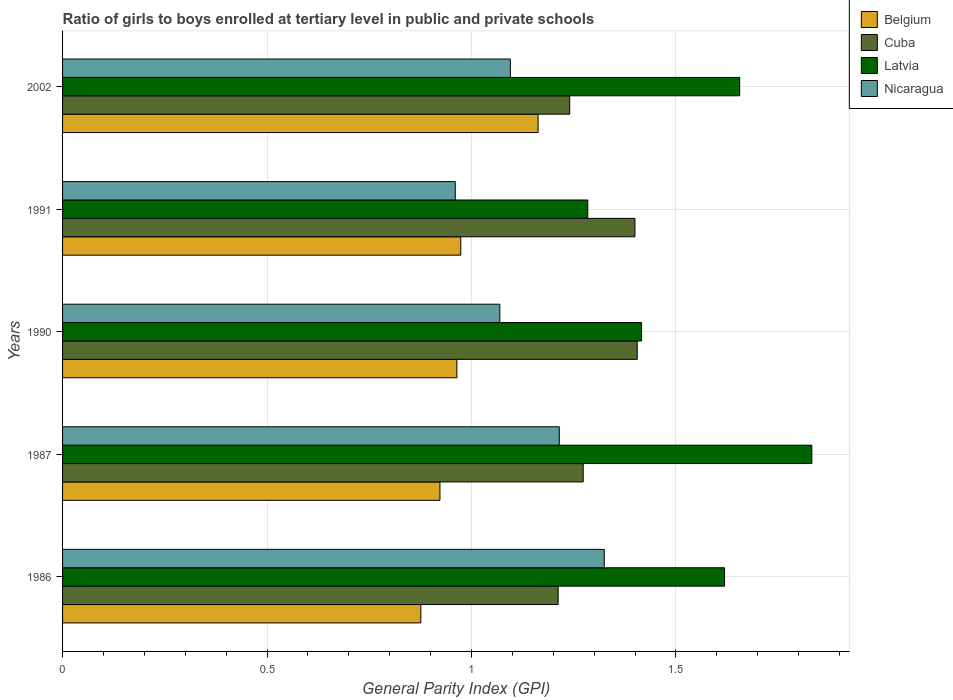Are the number of bars on each tick of the Y-axis equal?
Ensure brevity in your answer.  Yes. How many bars are there on the 1st tick from the top?
Provide a short and direct response. 4. What is the label of the 5th group of bars from the top?
Keep it short and to the point. 1986. In how many cases, is the number of bars for a given year not equal to the number of legend labels?
Your answer should be very brief. 0. What is the general parity index in Cuba in 2002?
Your response must be concise. 1.24. Across all years, what is the maximum general parity index in Cuba?
Give a very brief answer. 1.41. Across all years, what is the minimum general parity index in Cuba?
Provide a succinct answer. 1.21. What is the total general parity index in Belgium in the graph?
Your answer should be very brief. 4.9. What is the difference between the general parity index in Latvia in 1990 and that in 1991?
Your answer should be compact. 0.13. What is the difference between the general parity index in Nicaragua in 1991 and the general parity index in Cuba in 1986?
Make the answer very short. -0.25. What is the average general parity index in Nicaragua per year?
Offer a very short reply. 1.13. In the year 1987, what is the difference between the general parity index in Cuba and general parity index in Latvia?
Make the answer very short. -0.56. In how many years, is the general parity index in Latvia greater than 0.4 ?
Give a very brief answer. 5. What is the ratio of the general parity index in Latvia in 1991 to that in 2002?
Your answer should be compact. 0.78. Is the general parity index in Latvia in 1986 less than that in 2002?
Keep it short and to the point. Yes. Is the difference between the general parity index in Cuba in 1987 and 1991 greater than the difference between the general parity index in Latvia in 1987 and 1991?
Your response must be concise. No. What is the difference between the highest and the second highest general parity index in Latvia?
Give a very brief answer. 0.18. What is the difference between the highest and the lowest general parity index in Nicaragua?
Provide a succinct answer. 0.36. What does the 4th bar from the top in 2002 represents?
Your answer should be compact. Belgium. What does the 4th bar from the bottom in 1990 represents?
Your answer should be compact. Nicaragua. How many bars are there?
Your answer should be compact. 20. Are all the bars in the graph horizontal?
Your answer should be compact. Yes. Does the graph contain any zero values?
Your response must be concise. No. Does the graph contain grids?
Provide a short and direct response. Yes. How many legend labels are there?
Keep it short and to the point. 4. How are the legend labels stacked?
Provide a succinct answer. Vertical. What is the title of the graph?
Offer a very short reply. Ratio of girls to boys enrolled at tertiary level in public and private schools. What is the label or title of the X-axis?
Give a very brief answer. General Parity Index (GPI). What is the General Parity Index (GPI) in Belgium in 1986?
Keep it short and to the point. 0.88. What is the General Parity Index (GPI) in Cuba in 1986?
Keep it short and to the point. 1.21. What is the General Parity Index (GPI) in Latvia in 1986?
Provide a succinct answer. 1.62. What is the General Parity Index (GPI) in Nicaragua in 1986?
Keep it short and to the point. 1.32. What is the General Parity Index (GPI) of Belgium in 1987?
Make the answer very short. 0.92. What is the General Parity Index (GPI) in Cuba in 1987?
Give a very brief answer. 1.27. What is the General Parity Index (GPI) of Latvia in 1987?
Keep it short and to the point. 1.83. What is the General Parity Index (GPI) in Nicaragua in 1987?
Offer a very short reply. 1.21. What is the General Parity Index (GPI) in Belgium in 1990?
Provide a succinct answer. 0.96. What is the General Parity Index (GPI) of Cuba in 1990?
Your response must be concise. 1.41. What is the General Parity Index (GPI) of Latvia in 1990?
Your answer should be very brief. 1.42. What is the General Parity Index (GPI) in Nicaragua in 1990?
Provide a succinct answer. 1.07. What is the General Parity Index (GPI) in Belgium in 1991?
Your response must be concise. 0.97. What is the General Parity Index (GPI) in Cuba in 1991?
Give a very brief answer. 1.4. What is the General Parity Index (GPI) of Latvia in 1991?
Keep it short and to the point. 1.28. What is the General Parity Index (GPI) of Nicaragua in 1991?
Keep it short and to the point. 0.96. What is the General Parity Index (GPI) of Belgium in 2002?
Provide a succinct answer. 1.16. What is the General Parity Index (GPI) of Cuba in 2002?
Offer a very short reply. 1.24. What is the General Parity Index (GPI) of Latvia in 2002?
Provide a succinct answer. 1.66. What is the General Parity Index (GPI) in Nicaragua in 2002?
Provide a succinct answer. 1.1. Across all years, what is the maximum General Parity Index (GPI) in Belgium?
Your response must be concise. 1.16. Across all years, what is the maximum General Parity Index (GPI) of Cuba?
Keep it short and to the point. 1.41. Across all years, what is the maximum General Parity Index (GPI) of Latvia?
Ensure brevity in your answer.  1.83. Across all years, what is the maximum General Parity Index (GPI) of Nicaragua?
Ensure brevity in your answer.  1.32. Across all years, what is the minimum General Parity Index (GPI) in Belgium?
Provide a succinct answer. 0.88. Across all years, what is the minimum General Parity Index (GPI) in Cuba?
Keep it short and to the point. 1.21. Across all years, what is the minimum General Parity Index (GPI) in Latvia?
Ensure brevity in your answer.  1.28. Across all years, what is the minimum General Parity Index (GPI) of Nicaragua?
Provide a succinct answer. 0.96. What is the total General Parity Index (GPI) in Belgium in the graph?
Ensure brevity in your answer.  4.9. What is the total General Parity Index (GPI) in Cuba in the graph?
Provide a succinct answer. 6.53. What is the total General Parity Index (GPI) of Latvia in the graph?
Your answer should be very brief. 7.81. What is the total General Parity Index (GPI) in Nicaragua in the graph?
Make the answer very short. 5.66. What is the difference between the General Parity Index (GPI) of Belgium in 1986 and that in 1987?
Give a very brief answer. -0.05. What is the difference between the General Parity Index (GPI) of Cuba in 1986 and that in 1987?
Offer a very short reply. -0.06. What is the difference between the General Parity Index (GPI) in Latvia in 1986 and that in 1987?
Your answer should be very brief. -0.21. What is the difference between the General Parity Index (GPI) of Nicaragua in 1986 and that in 1987?
Provide a succinct answer. 0.11. What is the difference between the General Parity Index (GPI) of Belgium in 1986 and that in 1990?
Your answer should be compact. -0.09. What is the difference between the General Parity Index (GPI) in Cuba in 1986 and that in 1990?
Provide a short and direct response. -0.19. What is the difference between the General Parity Index (GPI) of Latvia in 1986 and that in 1990?
Keep it short and to the point. 0.2. What is the difference between the General Parity Index (GPI) of Nicaragua in 1986 and that in 1990?
Make the answer very short. 0.26. What is the difference between the General Parity Index (GPI) in Belgium in 1986 and that in 1991?
Ensure brevity in your answer.  -0.1. What is the difference between the General Parity Index (GPI) of Cuba in 1986 and that in 1991?
Your answer should be very brief. -0.19. What is the difference between the General Parity Index (GPI) in Latvia in 1986 and that in 1991?
Your answer should be very brief. 0.33. What is the difference between the General Parity Index (GPI) in Nicaragua in 1986 and that in 1991?
Make the answer very short. 0.36. What is the difference between the General Parity Index (GPI) of Belgium in 1986 and that in 2002?
Offer a very short reply. -0.29. What is the difference between the General Parity Index (GPI) in Cuba in 1986 and that in 2002?
Offer a terse response. -0.03. What is the difference between the General Parity Index (GPI) in Latvia in 1986 and that in 2002?
Ensure brevity in your answer.  -0.04. What is the difference between the General Parity Index (GPI) of Nicaragua in 1986 and that in 2002?
Provide a succinct answer. 0.23. What is the difference between the General Parity Index (GPI) of Belgium in 1987 and that in 1990?
Provide a succinct answer. -0.04. What is the difference between the General Parity Index (GPI) in Cuba in 1987 and that in 1990?
Make the answer very short. -0.13. What is the difference between the General Parity Index (GPI) of Latvia in 1987 and that in 1990?
Your answer should be compact. 0.42. What is the difference between the General Parity Index (GPI) of Nicaragua in 1987 and that in 1990?
Offer a very short reply. 0.15. What is the difference between the General Parity Index (GPI) of Belgium in 1987 and that in 1991?
Offer a terse response. -0.05. What is the difference between the General Parity Index (GPI) in Cuba in 1987 and that in 1991?
Make the answer very short. -0.13. What is the difference between the General Parity Index (GPI) of Latvia in 1987 and that in 1991?
Offer a terse response. 0.55. What is the difference between the General Parity Index (GPI) in Nicaragua in 1987 and that in 1991?
Provide a short and direct response. 0.25. What is the difference between the General Parity Index (GPI) of Belgium in 1987 and that in 2002?
Make the answer very short. -0.24. What is the difference between the General Parity Index (GPI) of Cuba in 1987 and that in 2002?
Your answer should be compact. 0.03. What is the difference between the General Parity Index (GPI) of Latvia in 1987 and that in 2002?
Your answer should be compact. 0.18. What is the difference between the General Parity Index (GPI) of Nicaragua in 1987 and that in 2002?
Provide a succinct answer. 0.12. What is the difference between the General Parity Index (GPI) in Belgium in 1990 and that in 1991?
Provide a short and direct response. -0.01. What is the difference between the General Parity Index (GPI) in Cuba in 1990 and that in 1991?
Your response must be concise. 0.01. What is the difference between the General Parity Index (GPI) of Latvia in 1990 and that in 1991?
Your answer should be very brief. 0.13. What is the difference between the General Parity Index (GPI) in Nicaragua in 1990 and that in 1991?
Keep it short and to the point. 0.11. What is the difference between the General Parity Index (GPI) in Belgium in 1990 and that in 2002?
Your answer should be very brief. -0.2. What is the difference between the General Parity Index (GPI) in Cuba in 1990 and that in 2002?
Your answer should be very brief. 0.17. What is the difference between the General Parity Index (GPI) in Latvia in 1990 and that in 2002?
Your response must be concise. -0.24. What is the difference between the General Parity Index (GPI) of Nicaragua in 1990 and that in 2002?
Your answer should be compact. -0.03. What is the difference between the General Parity Index (GPI) of Belgium in 1991 and that in 2002?
Ensure brevity in your answer.  -0.19. What is the difference between the General Parity Index (GPI) in Cuba in 1991 and that in 2002?
Ensure brevity in your answer.  0.16. What is the difference between the General Parity Index (GPI) of Latvia in 1991 and that in 2002?
Keep it short and to the point. -0.37. What is the difference between the General Parity Index (GPI) of Nicaragua in 1991 and that in 2002?
Your answer should be compact. -0.13. What is the difference between the General Parity Index (GPI) of Belgium in 1986 and the General Parity Index (GPI) of Cuba in 1987?
Your answer should be very brief. -0.4. What is the difference between the General Parity Index (GPI) in Belgium in 1986 and the General Parity Index (GPI) in Latvia in 1987?
Provide a short and direct response. -0.96. What is the difference between the General Parity Index (GPI) of Belgium in 1986 and the General Parity Index (GPI) of Nicaragua in 1987?
Offer a very short reply. -0.34. What is the difference between the General Parity Index (GPI) of Cuba in 1986 and the General Parity Index (GPI) of Latvia in 1987?
Ensure brevity in your answer.  -0.62. What is the difference between the General Parity Index (GPI) in Cuba in 1986 and the General Parity Index (GPI) in Nicaragua in 1987?
Your answer should be compact. -0. What is the difference between the General Parity Index (GPI) in Latvia in 1986 and the General Parity Index (GPI) in Nicaragua in 1987?
Give a very brief answer. 0.4. What is the difference between the General Parity Index (GPI) in Belgium in 1986 and the General Parity Index (GPI) in Cuba in 1990?
Your answer should be compact. -0.53. What is the difference between the General Parity Index (GPI) in Belgium in 1986 and the General Parity Index (GPI) in Latvia in 1990?
Your response must be concise. -0.54. What is the difference between the General Parity Index (GPI) in Belgium in 1986 and the General Parity Index (GPI) in Nicaragua in 1990?
Offer a very short reply. -0.19. What is the difference between the General Parity Index (GPI) in Cuba in 1986 and the General Parity Index (GPI) in Latvia in 1990?
Give a very brief answer. -0.2. What is the difference between the General Parity Index (GPI) in Cuba in 1986 and the General Parity Index (GPI) in Nicaragua in 1990?
Give a very brief answer. 0.14. What is the difference between the General Parity Index (GPI) in Latvia in 1986 and the General Parity Index (GPI) in Nicaragua in 1990?
Provide a short and direct response. 0.55. What is the difference between the General Parity Index (GPI) in Belgium in 1986 and the General Parity Index (GPI) in Cuba in 1991?
Provide a short and direct response. -0.52. What is the difference between the General Parity Index (GPI) of Belgium in 1986 and the General Parity Index (GPI) of Latvia in 1991?
Provide a succinct answer. -0.41. What is the difference between the General Parity Index (GPI) in Belgium in 1986 and the General Parity Index (GPI) in Nicaragua in 1991?
Your answer should be very brief. -0.08. What is the difference between the General Parity Index (GPI) of Cuba in 1986 and the General Parity Index (GPI) of Latvia in 1991?
Keep it short and to the point. -0.07. What is the difference between the General Parity Index (GPI) in Cuba in 1986 and the General Parity Index (GPI) in Nicaragua in 1991?
Make the answer very short. 0.25. What is the difference between the General Parity Index (GPI) of Latvia in 1986 and the General Parity Index (GPI) of Nicaragua in 1991?
Your response must be concise. 0.66. What is the difference between the General Parity Index (GPI) of Belgium in 1986 and the General Parity Index (GPI) of Cuba in 2002?
Your response must be concise. -0.36. What is the difference between the General Parity Index (GPI) in Belgium in 1986 and the General Parity Index (GPI) in Latvia in 2002?
Your answer should be very brief. -0.78. What is the difference between the General Parity Index (GPI) in Belgium in 1986 and the General Parity Index (GPI) in Nicaragua in 2002?
Give a very brief answer. -0.22. What is the difference between the General Parity Index (GPI) of Cuba in 1986 and the General Parity Index (GPI) of Latvia in 2002?
Offer a terse response. -0.44. What is the difference between the General Parity Index (GPI) of Cuba in 1986 and the General Parity Index (GPI) of Nicaragua in 2002?
Offer a terse response. 0.12. What is the difference between the General Parity Index (GPI) in Latvia in 1986 and the General Parity Index (GPI) in Nicaragua in 2002?
Ensure brevity in your answer.  0.52. What is the difference between the General Parity Index (GPI) in Belgium in 1987 and the General Parity Index (GPI) in Cuba in 1990?
Provide a succinct answer. -0.48. What is the difference between the General Parity Index (GPI) of Belgium in 1987 and the General Parity Index (GPI) of Latvia in 1990?
Your answer should be very brief. -0.49. What is the difference between the General Parity Index (GPI) of Belgium in 1987 and the General Parity Index (GPI) of Nicaragua in 1990?
Offer a terse response. -0.15. What is the difference between the General Parity Index (GPI) in Cuba in 1987 and the General Parity Index (GPI) in Latvia in 1990?
Ensure brevity in your answer.  -0.14. What is the difference between the General Parity Index (GPI) of Cuba in 1987 and the General Parity Index (GPI) of Nicaragua in 1990?
Give a very brief answer. 0.2. What is the difference between the General Parity Index (GPI) in Latvia in 1987 and the General Parity Index (GPI) in Nicaragua in 1990?
Provide a short and direct response. 0.76. What is the difference between the General Parity Index (GPI) of Belgium in 1987 and the General Parity Index (GPI) of Cuba in 1991?
Offer a terse response. -0.48. What is the difference between the General Parity Index (GPI) in Belgium in 1987 and the General Parity Index (GPI) in Latvia in 1991?
Offer a terse response. -0.36. What is the difference between the General Parity Index (GPI) in Belgium in 1987 and the General Parity Index (GPI) in Nicaragua in 1991?
Your response must be concise. -0.04. What is the difference between the General Parity Index (GPI) in Cuba in 1987 and the General Parity Index (GPI) in Latvia in 1991?
Your answer should be compact. -0.01. What is the difference between the General Parity Index (GPI) of Cuba in 1987 and the General Parity Index (GPI) of Nicaragua in 1991?
Ensure brevity in your answer.  0.31. What is the difference between the General Parity Index (GPI) in Latvia in 1987 and the General Parity Index (GPI) in Nicaragua in 1991?
Offer a very short reply. 0.87. What is the difference between the General Parity Index (GPI) in Belgium in 1987 and the General Parity Index (GPI) in Cuba in 2002?
Offer a terse response. -0.32. What is the difference between the General Parity Index (GPI) of Belgium in 1987 and the General Parity Index (GPI) of Latvia in 2002?
Ensure brevity in your answer.  -0.73. What is the difference between the General Parity Index (GPI) of Belgium in 1987 and the General Parity Index (GPI) of Nicaragua in 2002?
Keep it short and to the point. -0.17. What is the difference between the General Parity Index (GPI) of Cuba in 1987 and the General Parity Index (GPI) of Latvia in 2002?
Ensure brevity in your answer.  -0.38. What is the difference between the General Parity Index (GPI) in Cuba in 1987 and the General Parity Index (GPI) in Nicaragua in 2002?
Provide a short and direct response. 0.18. What is the difference between the General Parity Index (GPI) of Latvia in 1987 and the General Parity Index (GPI) of Nicaragua in 2002?
Make the answer very short. 0.74. What is the difference between the General Parity Index (GPI) of Belgium in 1990 and the General Parity Index (GPI) of Cuba in 1991?
Offer a terse response. -0.44. What is the difference between the General Parity Index (GPI) of Belgium in 1990 and the General Parity Index (GPI) of Latvia in 1991?
Your answer should be compact. -0.32. What is the difference between the General Parity Index (GPI) in Belgium in 1990 and the General Parity Index (GPI) in Nicaragua in 1991?
Make the answer very short. 0. What is the difference between the General Parity Index (GPI) in Cuba in 1990 and the General Parity Index (GPI) in Latvia in 1991?
Provide a short and direct response. 0.12. What is the difference between the General Parity Index (GPI) of Cuba in 1990 and the General Parity Index (GPI) of Nicaragua in 1991?
Make the answer very short. 0.45. What is the difference between the General Parity Index (GPI) of Latvia in 1990 and the General Parity Index (GPI) of Nicaragua in 1991?
Make the answer very short. 0.46. What is the difference between the General Parity Index (GPI) in Belgium in 1990 and the General Parity Index (GPI) in Cuba in 2002?
Keep it short and to the point. -0.28. What is the difference between the General Parity Index (GPI) in Belgium in 1990 and the General Parity Index (GPI) in Latvia in 2002?
Your response must be concise. -0.69. What is the difference between the General Parity Index (GPI) of Belgium in 1990 and the General Parity Index (GPI) of Nicaragua in 2002?
Your response must be concise. -0.13. What is the difference between the General Parity Index (GPI) in Cuba in 1990 and the General Parity Index (GPI) in Latvia in 2002?
Offer a terse response. -0.25. What is the difference between the General Parity Index (GPI) in Cuba in 1990 and the General Parity Index (GPI) in Nicaragua in 2002?
Your answer should be compact. 0.31. What is the difference between the General Parity Index (GPI) in Latvia in 1990 and the General Parity Index (GPI) in Nicaragua in 2002?
Offer a terse response. 0.32. What is the difference between the General Parity Index (GPI) in Belgium in 1991 and the General Parity Index (GPI) in Cuba in 2002?
Make the answer very short. -0.27. What is the difference between the General Parity Index (GPI) in Belgium in 1991 and the General Parity Index (GPI) in Latvia in 2002?
Ensure brevity in your answer.  -0.68. What is the difference between the General Parity Index (GPI) of Belgium in 1991 and the General Parity Index (GPI) of Nicaragua in 2002?
Offer a very short reply. -0.12. What is the difference between the General Parity Index (GPI) in Cuba in 1991 and the General Parity Index (GPI) in Latvia in 2002?
Your answer should be compact. -0.26. What is the difference between the General Parity Index (GPI) in Cuba in 1991 and the General Parity Index (GPI) in Nicaragua in 2002?
Provide a succinct answer. 0.3. What is the difference between the General Parity Index (GPI) of Latvia in 1991 and the General Parity Index (GPI) of Nicaragua in 2002?
Provide a succinct answer. 0.19. What is the average General Parity Index (GPI) in Belgium per year?
Your response must be concise. 0.98. What is the average General Parity Index (GPI) in Cuba per year?
Your answer should be very brief. 1.31. What is the average General Parity Index (GPI) of Latvia per year?
Offer a very short reply. 1.56. What is the average General Parity Index (GPI) in Nicaragua per year?
Ensure brevity in your answer.  1.13. In the year 1986, what is the difference between the General Parity Index (GPI) of Belgium and General Parity Index (GPI) of Cuba?
Your answer should be compact. -0.34. In the year 1986, what is the difference between the General Parity Index (GPI) of Belgium and General Parity Index (GPI) of Latvia?
Provide a short and direct response. -0.74. In the year 1986, what is the difference between the General Parity Index (GPI) of Belgium and General Parity Index (GPI) of Nicaragua?
Make the answer very short. -0.45. In the year 1986, what is the difference between the General Parity Index (GPI) of Cuba and General Parity Index (GPI) of Latvia?
Offer a terse response. -0.41. In the year 1986, what is the difference between the General Parity Index (GPI) of Cuba and General Parity Index (GPI) of Nicaragua?
Offer a very short reply. -0.11. In the year 1986, what is the difference between the General Parity Index (GPI) of Latvia and General Parity Index (GPI) of Nicaragua?
Make the answer very short. 0.29. In the year 1987, what is the difference between the General Parity Index (GPI) in Belgium and General Parity Index (GPI) in Cuba?
Your answer should be very brief. -0.35. In the year 1987, what is the difference between the General Parity Index (GPI) in Belgium and General Parity Index (GPI) in Latvia?
Give a very brief answer. -0.91. In the year 1987, what is the difference between the General Parity Index (GPI) in Belgium and General Parity Index (GPI) in Nicaragua?
Provide a succinct answer. -0.29. In the year 1987, what is the difference between the General Parity Index (GPI) in Cuba and General Parity Index (GPI) in Latvia?
Ensure brevity in your answer.  -0.56. In the year 1987, what is the difference between the General Parity Index (GPI) in Cuba and General Parity Index (GPI) in Nicaragua?
Provide a succinct answer. 0.06. In the year 1987, what is the difference between the General Parity Index (GPI) of Latvia and General Parity Index (GPI) of Nicaragua?
Your response must be concise. 0.62. In the year 1990, what is the difference between the General Parity Index (GPI) in Belgium and General Parity Index (GPI) in Cuba?
Offer a very short reply. -0.44. In the year 1990, what is the difference between the General Parity Index (GPI) in Belgium and General Parity Index (GPI) in Latvia?
Keep it short and to the point. -0.45. In the year 1990, what is the difference between the General Parity Index (GPI) in Belgium and General Parity Index (GPI) in Nicaragua?
Make the answer very short. -0.1. In the year 1990, what is the difference between the General Parity Index (GPI) of Cuba and General Parity Index (GPI) of Latvia?
Keep it short and to the point. -0.01. In the year 1990, what is the difference between the General Parity Index (GPI) of Cuba and General Parity Index (GPI) of Nicaragua?
Keep it short and to the point. 0.34. In the year 1990, what is the difference between the General Parity Index (GPI) of Latvia and General Parity Index (GPI) of Nicaragua?
Keep it short and to the point. 0.35. In the year 1991, what is the difference between the General Parity Index (GPI) in Belgium and General Parity Index (GPI) in Cuba?
Offer a very short reply. -0.43. In the year 1991, what is the difference between the General Parity Index (GPI) in Belgium and General Parity Index (GPI) in Latvia?
Your answer should be very brief. -0.31. In the year 1991, what is the difference between the General Parity Index (GPI) in Belgium and General Parity Index (GPI) in Nicaragua?
Your answer should be very brief. 0.01. In the year 1991, what is the difference between the General Parity Index (GPI) of Cuba and General Parity Index (GPI) of Latvia?
Your answer should be compact. 0.12. In the year 1991, what is the difference between the General Parity Index (GPI) in Cuba and General Parity Index (GPI) in Nicaragua?
Offer a very short reply. 0.44. In the year 1991, what is the difference between the General Parity Index (GPI) of Latvia and General Parity Index (GPI) of Nicaragua?
Keep it short and to the point. 0.32. In the year 2002, what is the difference between the General Parity Index (GPI) of Belgium and General Parity Index (GPI) of Cuba?
Your answer should be very brief. -0.08. In the year 2002, what is the difference between the General Parity Index (GPI) in Belgium and General Parity Index (GPI) in Latvia?
Offer a terse response. -0.49. In the year 2002, what is the difference between the General Parity Index (GPI) of Belgium and General Parity Index (GPI) of Nicaragua?
Make the answer very short. 0.07. In the year 2002, what is the difference between the General Parity Index (GPI) of Cuba and General Parity Index (GPI) of Latvia?
Make the answer very short. -0.42. In the year 2002, what is the difference between the General Parity Index (GPI) of Cuba and General Parity Index (GPI) of Nicaragua?
Provide a short and direct response. 0.14. In the year 2002, what is the difference between the General Parity Index (GPI) in Latvia and General Parity Index (GPI) in Nicaragua?
Provide a short and direct response. 0.56. What is the ratio of the General Parity Index (GPI) of Belgium in 1986 to that in 1987?
Provide a short and direct response. 0.95. What is the ratio of the General Parity Index (GPI) in Cuba in 1986 to that in 1987?
Give a very brief answer. 0.95. What is the ratio of the General Parity Index (GPI) in Latvia in 1986 to that in 1987?
Offer a very short reply. 0.88. What is the ratio of the General Parity Index (GPI) in Nicaragua in 1986 to that in 1987?
Offer a terse response. 1.09. What is the ratio of the General Parity Index (GPI) in Belgium in 1986 to that in 1990?
Your answer should be very brief. 0.91. What is the ratio of the General Parity Index (GPI) in Cuba in 1986 to that in 1990?
Offer a terse response. 0.86. What is the ratio of the General Parity Index (GPI) in Latvia in 1986 to that in 1990?
Give a very brief answer. 1.14. What is the ratio of the General Parity Index (GPI) in Nicaragua in 1986 to that in 1990?
Give a very brief answer. 1.24. What is the ratio of the General Parity Index (GPI) in Belgium in 1986 to that in 1991?
Keep it short and to the point. 0.9. What is the ratio of the General Parity Index (GPI) of Cuba in 1986 to that in 1991?
Ensure brevity in your answer.  0.87. What is the ratio of the General Parity Index (GPI) in Latvia in 1986 to that in 1991?
Offer a terse response. 1.26. What is the ratio of the General Parity Index (GPI) in Nicaragua in 1986 to that in 1991?
Provide a short and direct response. 1.38. What is the ratio of the General Parity Index (GPI) in Belgium in 1986 to that in 2002?
Provide a succinct answer. 0.75. What is the ratio of the General Parity Index (GPI) in Cuba in 1986 to that in 2002?
Your answer should be compact. 0.98. What is the ratio of the General Parity Index (GPI) in Latvia in 1986 to that in 2002?
Your answer should be compact. 0.98. What is the ratio of the General Parity Index (GPI) in Nicaragua in 1986 to that in 2002?
Provide a short and direct response. 1.21. What is the ratio of the General Parity Index (GPI) in Cuba in 1987 to that in 1990?
Ensure brevity in your answer.  0.91. What is the ratio of the General Parity Index (GPI) in Latvia in 1987 to that in 1990?
Your response must be concise. 1.29. What is the ratio of the General Parity Index (GPI) of Nicaragua in 1987 to that in 1990?
Provide a short and direct response. 1.14. What is the ratio of the General Parity Index (GPI) of Belgium in 1987 to that in 1991?
Make the answer very short. 0.95. What is the ratio of the General Parity Index (GPI) in Cuba in 1987 to that in 1991?
Offer a terse response. 0.91. What is the ratio of the General Parity Index (GPI) in Latvia in 1987 to that in 1991?
Give a very brief answer. 1.43. What is the ratio of the General Parity Index (GPI) of Nicaragua in 1987 to that in 1991?
Provide a succinct answer. 1.26. What is the ratio of the General Parity Index (GPI) in Belgium in 1987 to that in 2002?
Your response must be concise. 0.79. What is the ratio of the General Parity Index (GPI) of Cuba in 1987 to that in 2002?
Your answer should be very brief. 1.03. What is the ratio of the General Parity Index (GPI) of Latvia in 1987 to that in 2002?
Your answer should be very brief. 1.11. What is the ratio of the General Parity Index (GPI) of Nicaragua in 1987 to that in 2002?
Offer a very short reply. 1.11. What is the ratio of the General Parity Index (GPI) in Belgium in 1990 to that in 1991?
Make the answer very short. 0.99. What is the ratio of the General Parity Index (GPI) of Cuba in 1990 to that in 1991?
Keep it short and to the point. 1. What is the ratio of the General Parity Index (GPI) of Latvia in 1990 to that in 1991?
Give a very brief answer. 1.1. What is the ratio of the General Parity Index (GPI) in Nicaragua in 1990 to that in 1991?
Your answer should be very brief. 1.11. What is the ratio of the General Parity Index (GPI) of Belgium in 1990 to that in 2002?
Your response must be concise. 0.83. What is the ratio of the General Parity Index (GPI) of Cuba in 1990 to that in 2002?
Keep it short and to the point. 1.13. What is the ratio of the General Parity Index (GPI) in Latvia in 1990 to that in 2002?
Your answer should be very brief. 0.86. What is the ratio of the General Parity Index (GPI) of Nicaragua in 1990 to that in 2002?
Provide a short and direct response. 0.98. What is the ratio of the General Parity Index (GPI) in Belgium in 1991 to that in 2002?
Offer a terse response. 0.84. What is the ratio of the General Parity Index (GPI) in Cuba in 1991 to that in 2002?
Ensure brevity in your answer.  1.13. What is the ratio of the General Parity Index (GPI) in Latvia in 1991 to that in 2002?
Your answer should be compact. 0.78. What is the ratio of the General Parity Index (GPI) of Nicaragua in 1991 to that in 2002?
Give a very brief answer. 0.88. What is the difference between the highest and the second highest General Parity Index (GPI) of Belgium?
Give a very brief answer. 0.19. What is the difference between the highest and the second highest General Parity Index (GPI) of Cuba?
Provide a short and direct response. 0.01. What is the difference between the highest and the second highest General Parity Index (GPI) in Latvia?
Make the answer very short. 0.18. What is the difference between the highest and the second highest General Parity Index (GPI) in Nicaragua?
Make the answer very short. 0.11. What is the difference between the highest and the lowest General Parity Index (GPI) of Belgium?
Your answer should be compact. 0.29. What is the difference between the highest and the lowest General Parity Index (GPI) in Cuba?
Your answer should be very brief. 0.19. What is the difference between the highest and the lowest General Parity Index (GPI) in Latvia?
Make the answer very short. 0.55. What is the difference between the highest and the lowest General Parity Index (GPI) in Nicaragua?
Give a very brief answer. 0.36. 